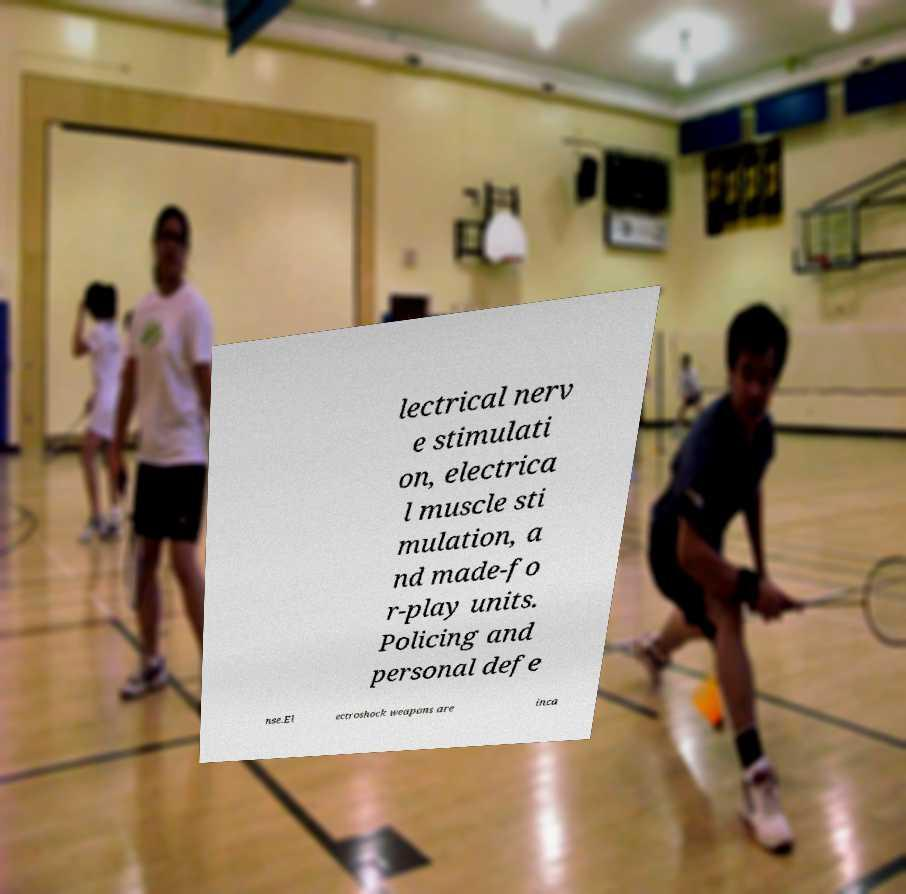Please identify and transcribe the text found in this image. lectrical nerv e stimulati on, electrica l muscle sti mulation, a nd made-fo r-play units. Policing and personal defe nse.El ectroshock weapons are inca 